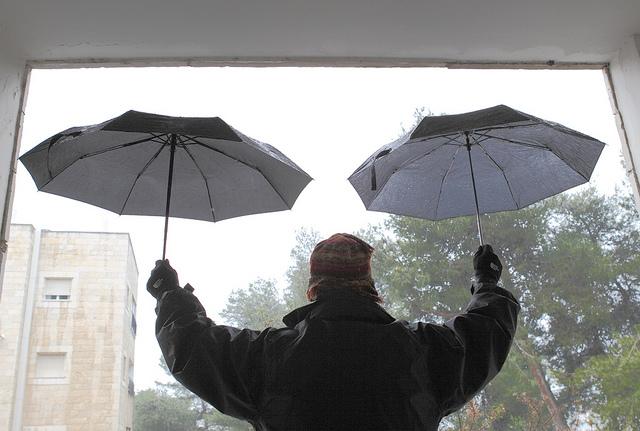Is it raining?
Short answer required. Yes. How many objects is this person holding?
Answer briefly. 2. Why does he have two umbrella?
Keep it brief. Because it is raining. 